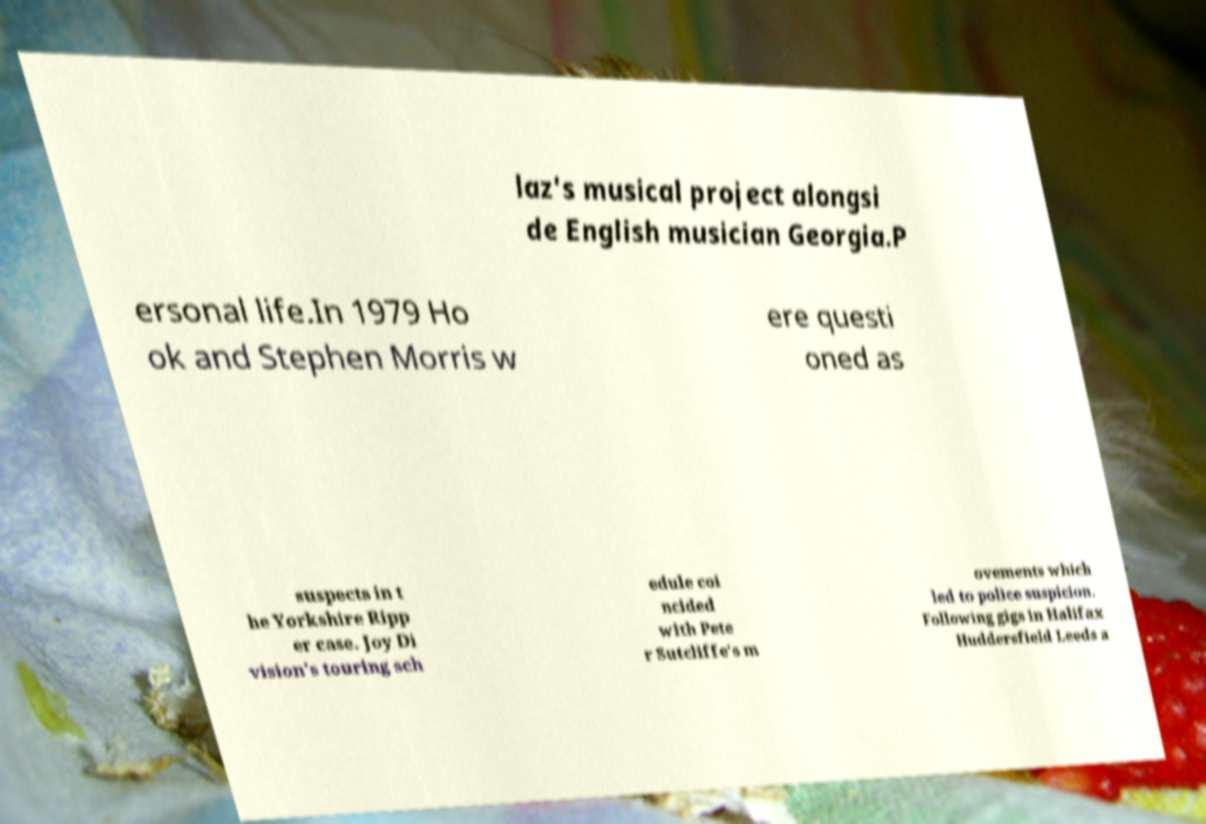Could you extract and type out the text from this image? laz's musical project alongsi de English musician Georgia.P ersonal life.In 1979 Ho ok and Stephen Morris w ere questi oned as suspects in t he Yorkshire Ripp er case. Joy Di vision's touring sch edule coi ncided with Pete r Sutcliffe's m ovements which led to police suspicion. Following gigs in Halifax Huddersfield Leeds a 